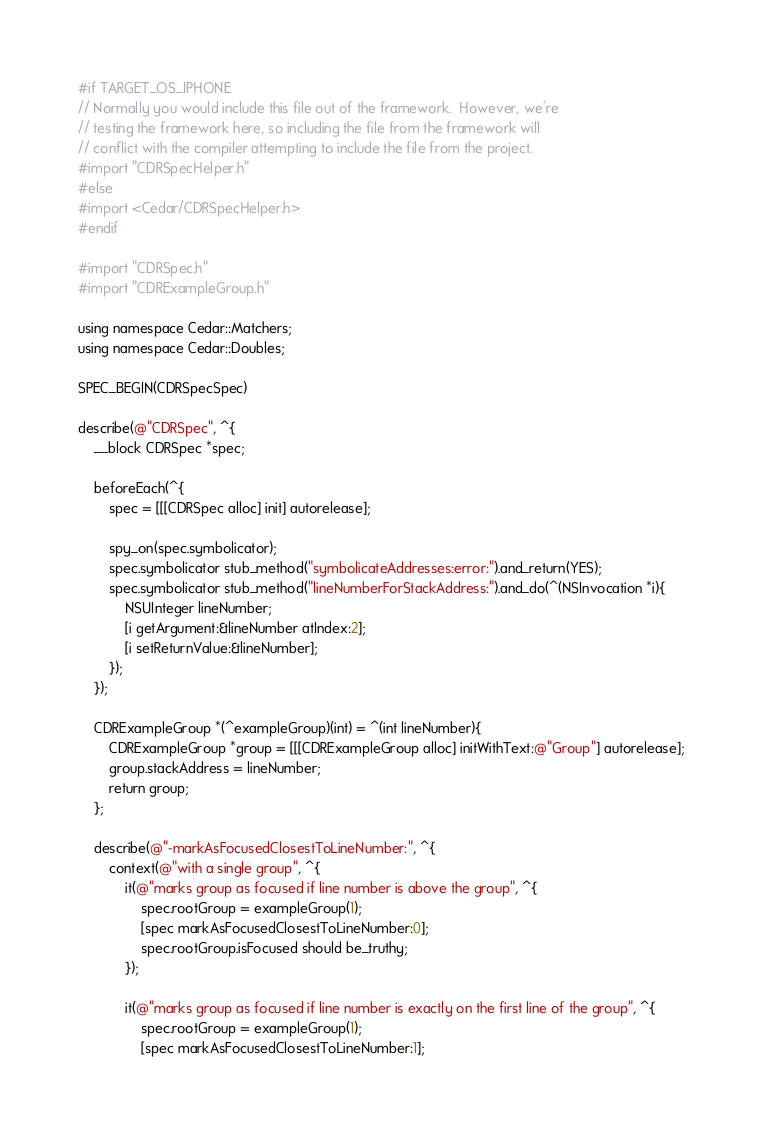Convert code to text. <code><loc_0><loc_0><loc_500><loc_500><_ObjectiveC_>#if TARGET_OS_IPHONE
// Normally you would include this file out of the framework.  However, we're
// testing the framework here, so including the file from the framework will
// conflict with the compiler attempting to include the file from the project.
#import "CDRSpecHelper.h"
#else
#import <Cedar/CDRSpecHelper.h>
#endif

#import "CDRSpec.h"
#import "CDRExampleGroup.h"

using namespace Cedar::Matchers;
using namespace Cedar::Doubles;

SPEC_BEGIN(CDRSpecSpec)

describe(@"CDRSpec", ^{
    __block CDRSpec *spec;

    beforeEach(^{
        spec = [[[CDRSpec alloc] init] autorelease];

        spy_on(spec.symbolicator);
        spec.symbolicator stub_method("symbolicateAddresses:error:").and_return(YES);
        spec.symbolicator stub_method("lineNumberForStackAddress:").and_do(^(NSInvocation *i){
            NSUInteger lineNumber;
            [i getArgument:&lineNumber atIndex:2];
            [i setReturnValue:&lineNumber];
        });
    });

    CDRExampleGroup *(^exampleGroup)(int) = ^(int lineNumber){
        CDRExampleGroup *group = [[[CDRExampleGroup alloc] initWithText:@"Group"] autorelease];
        group.stackAddress = lineNumber;
        return group;
    };

    describe(@"-markAsFocusedClosestToLineNumber:", ^{
        context(@"with a single group", ^{
            it(@"marks group as focused if line number is above the group", ^{
                spec.rootGroup = exampleGroup(1);
                [spec markAsFocusedClosestToLineNumber:0];
                spec.rootGroup.isFocused should be_truthy;
            });

            it(@"marks group as focused if line number is exactly on the first line of the group", ^{
                spec.rootGroup = exampleGroup(1);
                [spec markAsFocusedClosestToLineNumber:1];</code> 